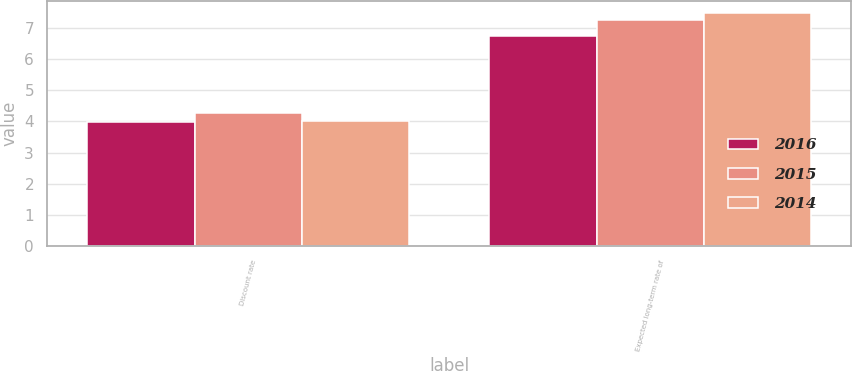Convert chart to OTSL. <chart><loc_0><loc_0><loc_500><loc_500><stacked_bar_chart><ecel><fcel>Discount rate<fcel>Expected long-term rate of<nl><fcel>2016<fcel>3.97<fcel>6.75<nl><fcel>2015<fcel>4.27<fcel>7.25<nl><fcel>2014<fcel>4<fcel>7.5<nl></chart> 